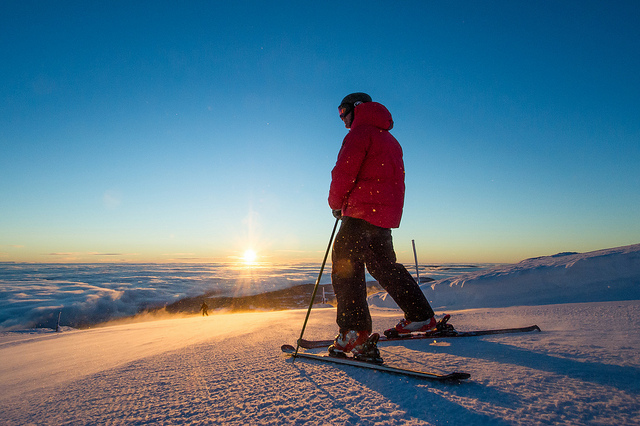<image>Is the sun going up or coming down? It is ambiguous whether the sun is going up or coming down. How long has this snow been here? It is unknown how long the snow has been there. How long has this snow been here? I don't know how long this snow has been here. It can be for months or just a day. Is the sun going up or coming down? I don't know if the sun is going up or coming down. It can be seen both coming down and going down. 